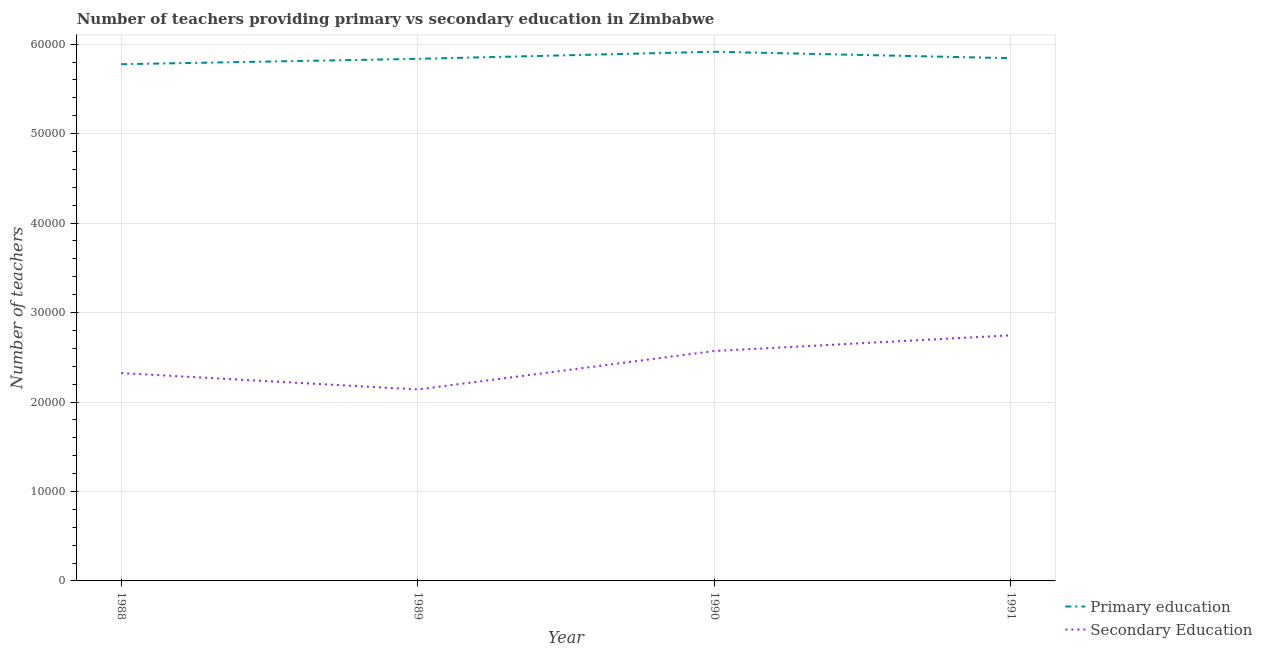How many different coloured lines are there?
Make the answer very short. 2. Does the line corresponding to number of secondary teachers intersect with the line corresponding to number of primary teachers?
Make the answer very short. No. Is the number of lines equal to the number of legend labels?
Keep it short and to the point. Yes. What is the number of primary teachers in 1990?
Offer a terse response. 5.92e+04. Across all years, what is the maximum number of primary teachers?
Ensure brevity in your answer.  5.92e+04. Across all years, what is the minimum number of secondary teachers?
Provide a short and direct response. 2.14e+04. In which year was the number of secondary teachers minimum?
Make the answer very short. 1989. What is the total number of secondary teachers in the graph?
Your response must be concise. 9.78e+04. What is the difference between the number of secondary teachers in 1989 and that in 1991?
Your answer should be compact. -6055. What is the difference between the number of primary teachers in 1991 and the number of secondary teachers in 1990?
Offer a very short reply. 3.27e+04. What is the average number of secondary teachers per year?
Your answer should be very brief. 2.44e+04. In the year 1988, what is the difference between the number of secondary teachers and number of primary teachers?
Provide a short and direct response. -3.45e+04. In how many years, is the number of secondary teachers greater than 54000?
Provide a short and direct response. 0. What is the ratio of the number of secondary teachers in 1988 to that in 1991?
Your response must be concise. 0.85. Is the difference between the number of primary teachers in 1990 and 1991 greater than the difference between the number of secondary teachers in 1990 and 1991?
Ensure brevity in your answer.  Yes. What is the difference between the highest and the second highest number of secondary teachers?
Give a very brief answer. 1756. What is the difference between the highest and the lowest number of primary teachers?
Keep it short and to the point. 1392. Is the sum of the number of primary teachers in 1989 and 1990 greater than the maximum number of secondary teachers across all years?
Offer a very short reply. Yes. Does the graph contain any zero values?
Ensure brevity in your answer.  No. What is the title of the graph?
Offer a very short reply. Number of teachers providing primary vs secondary education in Zimbabwe. What is the label or title of the X-axis?
Provide a succinct answer. Year. What is the label or title of the Y-axis?
Ensure brevity in your answer.  Number of teachers. What is the Number of teachers of Primary education in 1988?
Ensure brevity in your answer.  5.78e+04. What is the Number of teachers in Secondary Education in 1988?
Provide a succinct answer. 2.32e+04. What is the Number of teachers of Primary education in 1989?
Offer a very short reply. 5.84e+04. What is the Number of teachers in Secondary Education in 1989?
Provide a succinct answer. 2.14e+04. What is the Number of teachers of Primary education in 1990?
Your response must be concise. 5.92e+04. What is the Number of teachers in Secondary Education in 1990?
Offer a terse response. 2.57e+04. What is the Number of teachers in Primary education in 1991?
Provide a succinct answer. 5.84e+04. What is the Number of teachers in Secondary Education in 1991?
Your answer should be very brief. 2.75e+04. Across all years, what is the maximum Number of teachers in Primary education?
Your response must be concise. 5.92e+04. Across all years, what is the maximum Number of teachers of Secondary Education?
Give a very brief answer. 2.75e+04. Across all years, what is the minimum Number of teachers of Primary education?
Provide a succinct answer. 5.78e+04. Across all years, what is the minimum Number of teachers in Secondary Education?
Your answer should be compact. 2.14e+04. What is the total Number of teachers of Primary education in the graph?
Give a very brief answer. 2.34e+05. What is the total Number of teachers of Secondary Education in the graph?
Your response must be concise. 9.78e+04. What is the difference between the Number of teachers of Primary education in 1988 and that in 1989?
Keep it short and to the point. -600. What is the difference between the Number of teachers in Secondary Education in 1988 and that in 1989?
Ensure brevity in your answer.  1830. What is the difference between the Number of teachers in Primary education in 1988 and that in 1990?
Your answer should be very brief. -1392. What is the difference between the Number of teachers in Secondary Education in 1988 and that in 1990?
Your answer should be compact. -2469. What is the difference between the Number of teachers in Primary education in 1988 and that in 1991?
Your response must be concise. -674. What is the difference between the Number of teachers in Secondary Education in 1988 and that in 1991?
Provide a succinct answer. -4225. What is the difference between the Number of teachers in Primary education in 1989 and that in 1990?
Your answer should be very brief. -792. What is the difference between the Number of teachers in Secondary Education in 1989 and that in 1990?
Offer a very short reply. -4299. What is the difference between the Number of teachers of Primary education in 1989 and that in 1991?
Make the answer very short. -74. What is the difference between the Number of teachers of Secondary Education in 1989 and that in 1991?
Offer a very short reply. -6055. What is the difference between the Number of teachers in Primary education in 1990 and that in 1991?
Offer a terse response. 718. What is the difference between the Number of teachers of Secondary Education in 1990 and that in 1991?
Your answer should be compact. -1756. What is the difference between the Number of teachers of Primary education in 1988 and the Number of teachers of Secondary Education in 1989?
Your answer should be compact. 3.64e+04. What is the difference between the Number of teachers in Primary education in 1988 and the Number of teachers in Secondary Education in 1990?
Offer a very short reply. 3.21e+04. What is the difference between the Number of teachers in Primary education in 1988 and the Number of teachers in Secondary Education in 1991?
Your response must be concise. 3.03e+04. What is the difference between the Number of teachers in Primary education in 1989 and the Number of teachers in Secondary Education in 1990?
Provide a succinct answer. 3.27e+04. What is the difference between the Number of teachers in Primary education in 1989 and the Number of teachers in Secondary Education in 1991?
Offer a terse response. 3.09e+04. What is the difference between the Number of teachers in Primary education in 1990 and the Number of teachers in Secondary Education in 1991?
Make the answer very short. 3.17e+04. What is the average Number of teachers of Primary education per year?
Your answer should be compact. 5.84e+04. What is the average Number of teachers of Secondary Education per year?
Your answer should be compact. 2.44e+04. In the year 1988, what is the difference between the Number of teachers in Primary education and Number of teachers in Secondary Education?
Offer a terse response. 3.45e+04. In the year 1989, what is the difference between the Number of teachers of Primary education and Number of teachers of Secondary Education?
Provide a succinct answer. 3.70e+04. In the year 1990, what is the difference between the Number of teachers of Primary education and Number of teachers of Secondary Education?
Provide a succinct answer. 3.35e+04. In the year 1991, what is the difference between the Number of teachers in Primary education and Number of teachers in Secondary Education?
Offer a very short reply. 3.10e+04. What is the ratio of the Number of teachers of Secondary Education in 1988 to that in 1989?
Make the answer very short. 1.09. What is the ratio of the Number of teachers of Primary education in 1988 to that in 1990?
Your response must be concise. 0.98. What is the ratio of the Number of teachers of Secondary Education in 1988 to that in 1990?
Your answer should be compact. 0.9. What is the ratio of the Number of teachers in Primary education in 1988 to that in 1991?
Offer a terse response. 0.99. What is the ratio of the Number of teachers in Secondary Education in 1988 to that in 1991?
Your answer should be compact. 0.85. What is the ratio of the Number of teachers in Primary education in 1989 to that in 1990?
Keep it short and to the point. 0.99. What is the ratio of the Number of teachers of Secondary Education in 1989 to that in 1990?
Your answer should be very brief. 0.83. What is the ratio of the Number of teachers in Secondary Education in 1989 to that in 1991?
Give a very brief answer. 0.78. What is the ratio of the Number of teachers of Primary education in 1990 to that in 1991?
Your response must be concise. 1.01. What is the ratio of the Number of teachers of Secondary Education in 1990 to that in 1991?
Ensure brevity in your answer.  0.94. What is the difference between the highest and the second highest Number of teachers of Primary education?
Your answer should be compact. 718. What is the difference between the highest and the second highest Number of teachers in Secondary Education?
Ensure brevity in your answer.  1756. What is the difference between the highest and the lowest Number of teachers in Primary education?
Make the answer very short. 1392. What is the difference between the highest and the lowest Number of teachers in Secondary Education?
Keep it short and to the point. 6055. 